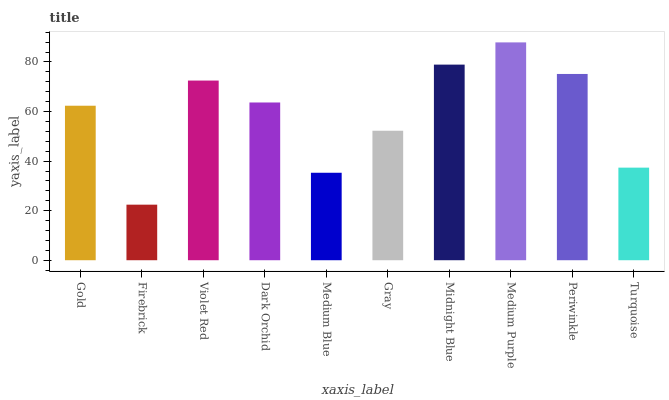Is Firebrick the minimum?
Answer yes or no. Yes. Is Medium Purple the maximum?
Answer yes or no. Yes. Is Violet Red the minimum?
Answer yes or no. No. Is Violet Red the maximum?
Answer yes or no. No. Is Violet Red greater than Firebrick?
Answer yes or no. Yes. Is Firebrick less than Violet Red?
Answer yes or no. Yes. Is Firebrick greater than Violet Red?
Answer yes or no. No. Is Violet Red less than Firebrick?
Answer yes or no. No. Is Dark Orchid the high median?
Answer yes or no. Yes. Is Gold the low median?
Answer yes or no. Yes. Is Midnight Blue the high median?
Answer yes or no. No. Is Midnight Blue the low median?
Answer yes or no. No. 